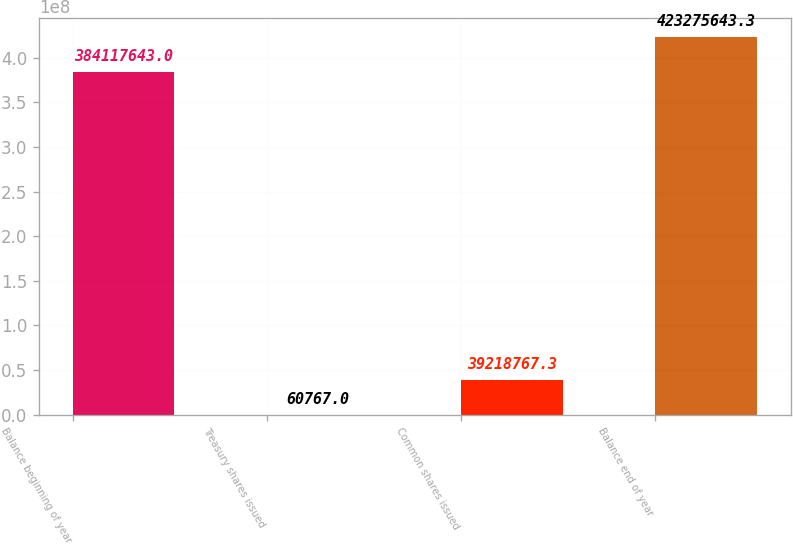Convert chart to OTSL. <chart><loc_0><loc_0><loc_500><loc_500><bar_chart><fcel>Balance beginning of year<fcel>Treasury shares issued<fcel>Common shares issued<fcel>Balance end of year<nl><fcel>3.84118e+08<fcel>60767<fcel>3.92188e+07<fcel>4.23276e+08<nl></chart> 